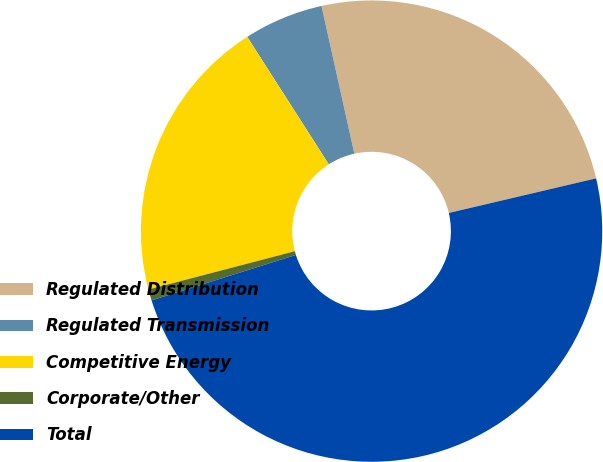Convert chart to OTSL. <chart><loc_0><loc_0><loc_500><loc_500><pie_chart><fcel>Regulated Distribution<fcel>Regulated Transmission<fcel>Competitive Energy<fcel>Corporate/Other<fcel>Total<nl><fcel>24.81%<fcel>5.58%<fcel>20.01%<fcel>0.78%<fcel>48.82%<nl></chart> 